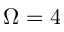<formula> <loc_0><loc_0><loc_500><loc_500>\Omega = 4</formula> 